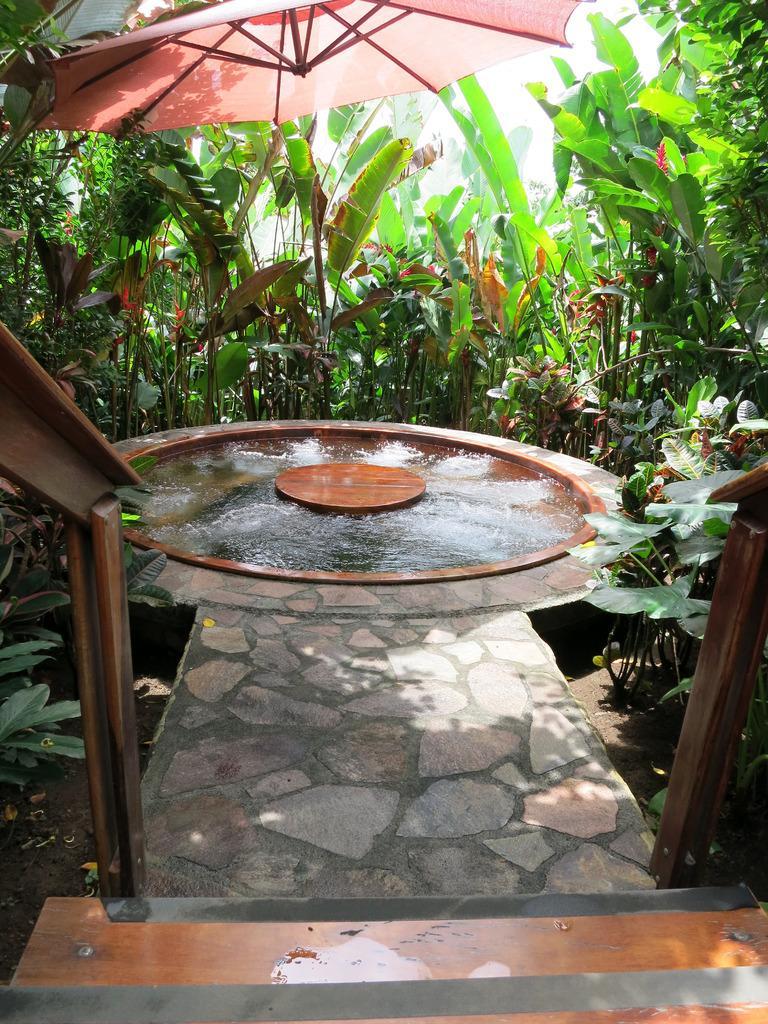Could you give a brief overview of what you see in this image? In this picture we can see an umbrella, water, steps, path and in the background we can see trees. 